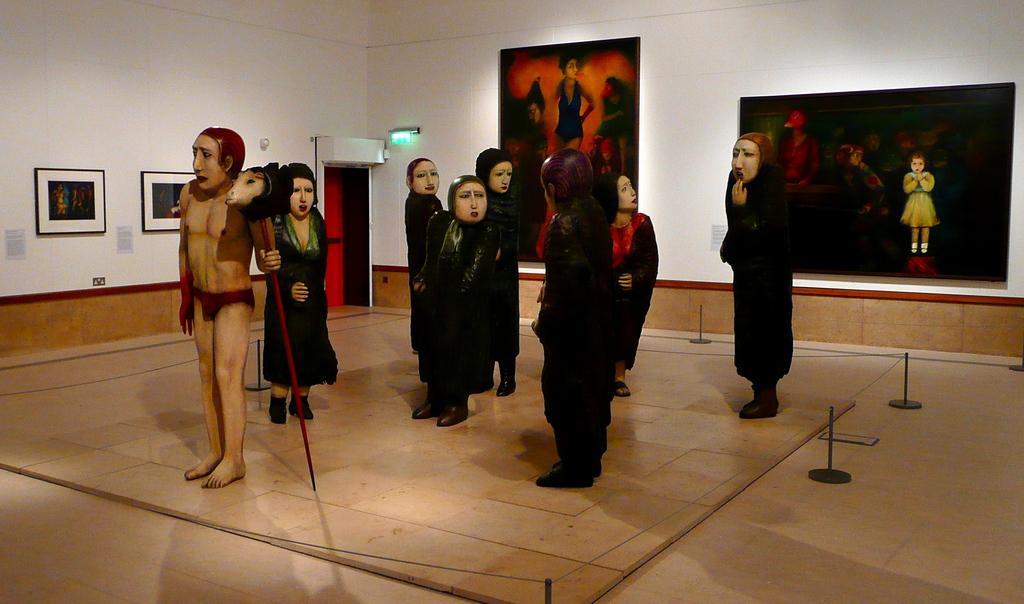Describe this image in one or two sentences. In this image, we can see some statues and there are some photos on the wall, we can see the door. 